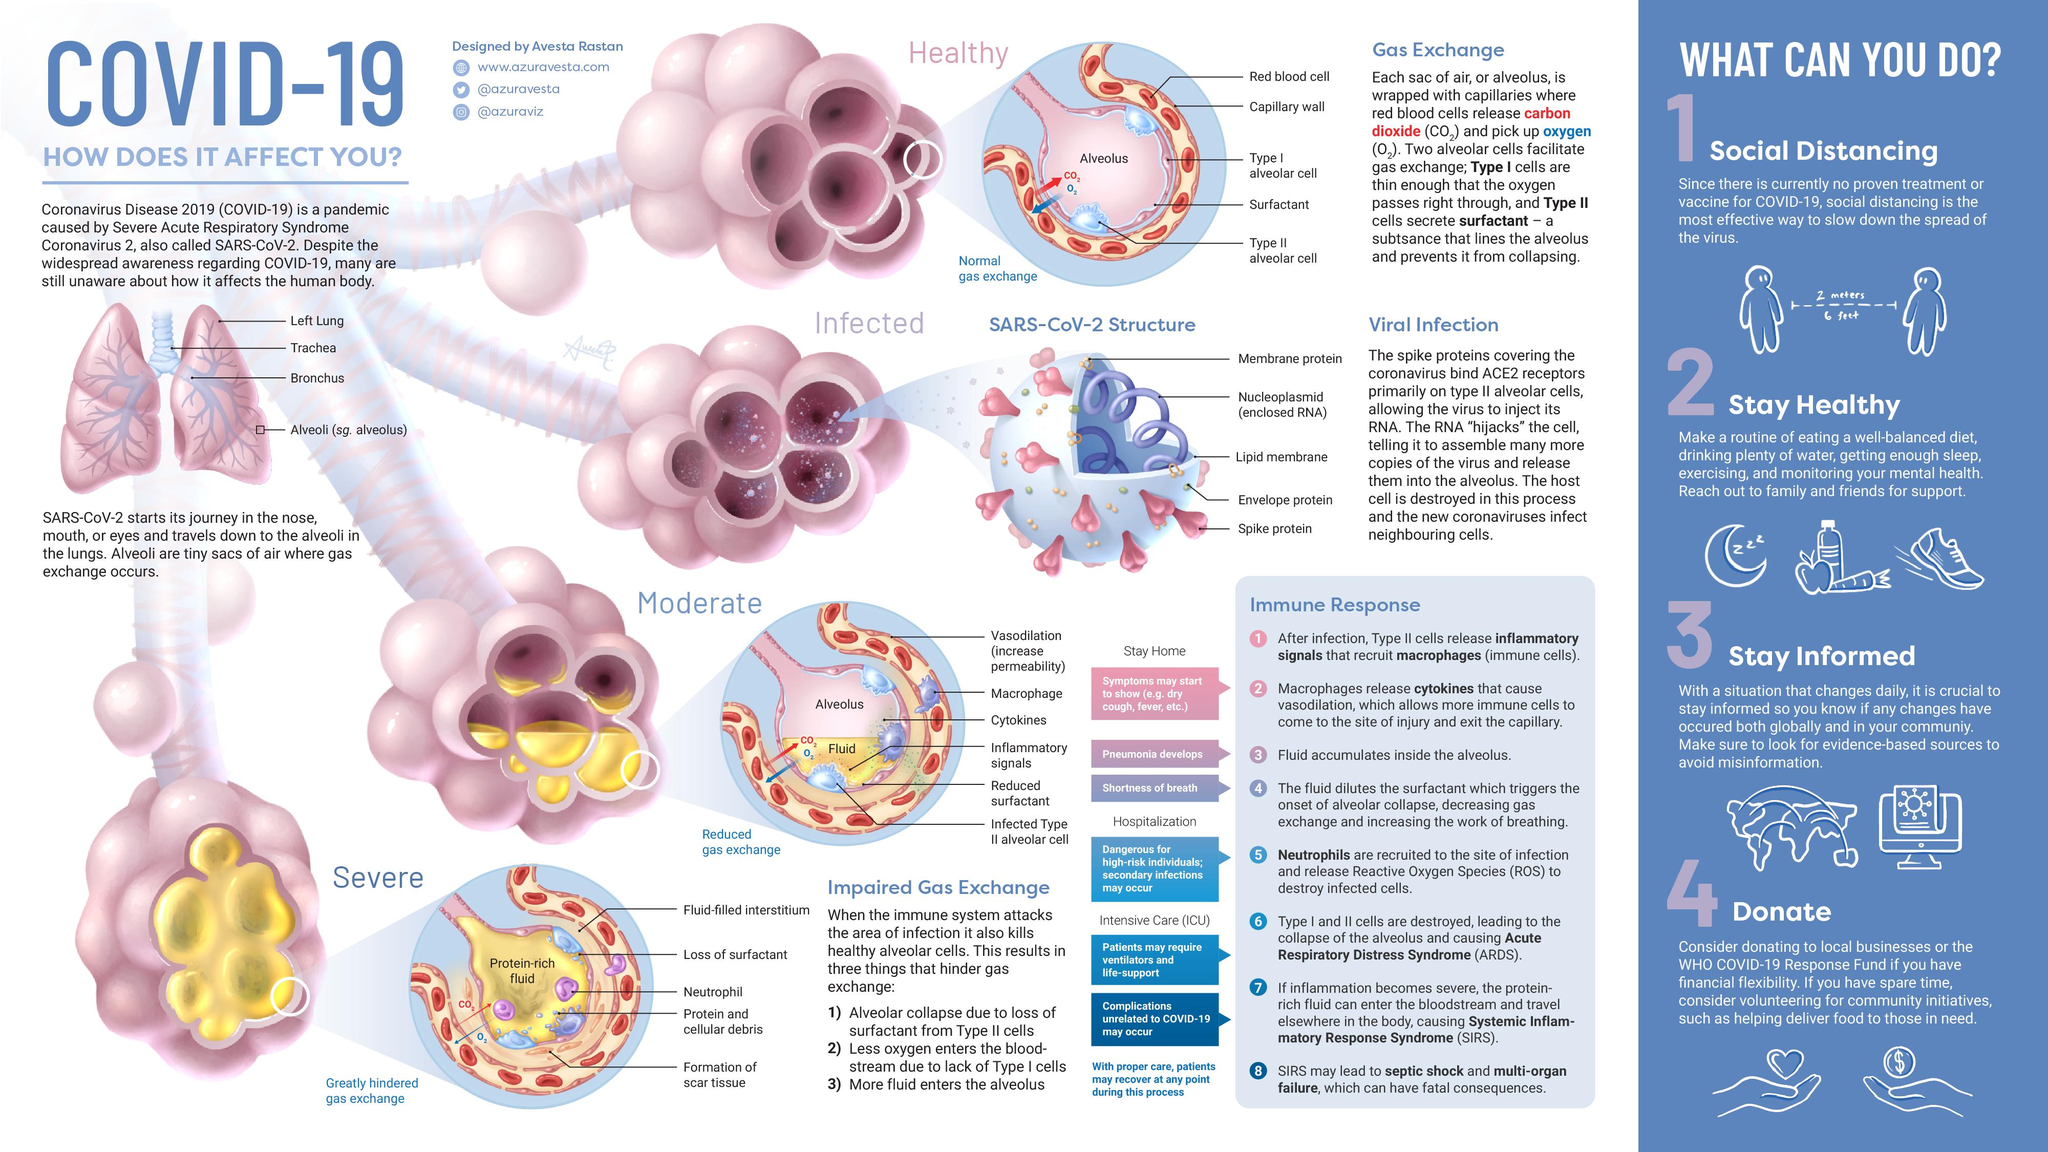Identify some key points in this picture. The SARS-COV-2 virus is composed of three key proteins: the membrane protein, the envelope protein, and the spike protein. These proteins play important roles in the structure and function of the virus, and are the focus of ongoing research and efforts to develop effective treatments and vaccines. Pneumonia develops when fluid accumulates inside the alveolus. If you have spare time, I suggest volunteering for community initiatives as a means of making a positive impact in your community. In addition to social distancing, there are three other ways to stay healthy, informed, and support the community during the pandemic: staying healthy, staying informed, and donating. In the alveoli, reduced gas exchange occurs at a moderate stage of infection. 